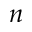<formula> <loc_0><loc_0><loc_500><loc_500>n</formula> 